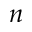<formula> <loc_0><loc_0><loc_500><loc_500>n</formula> 